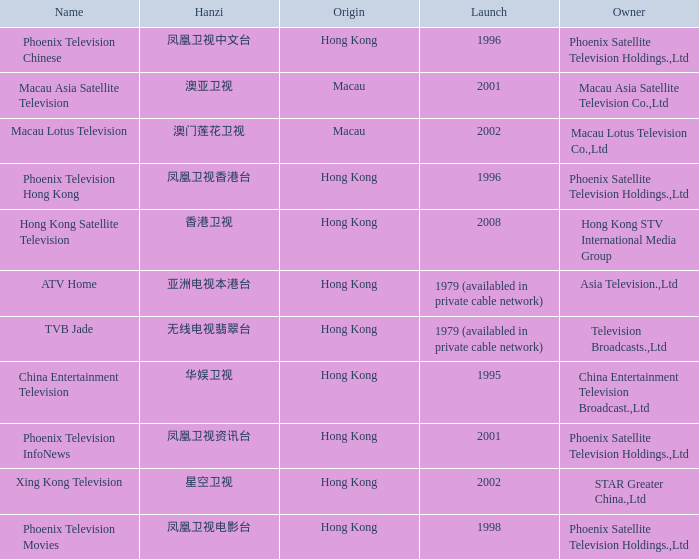Which company launched in 1996 and has a Hanzi of 凤凰卫视中文台? Phoenix Television Chinese. 